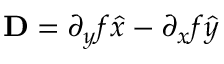<formula> <loc_0><loc_0><loc_500><loc_500>{ D } = \partial _ { y } f \hat { x } - \partial _ { x } f \hat { y }</formula> 